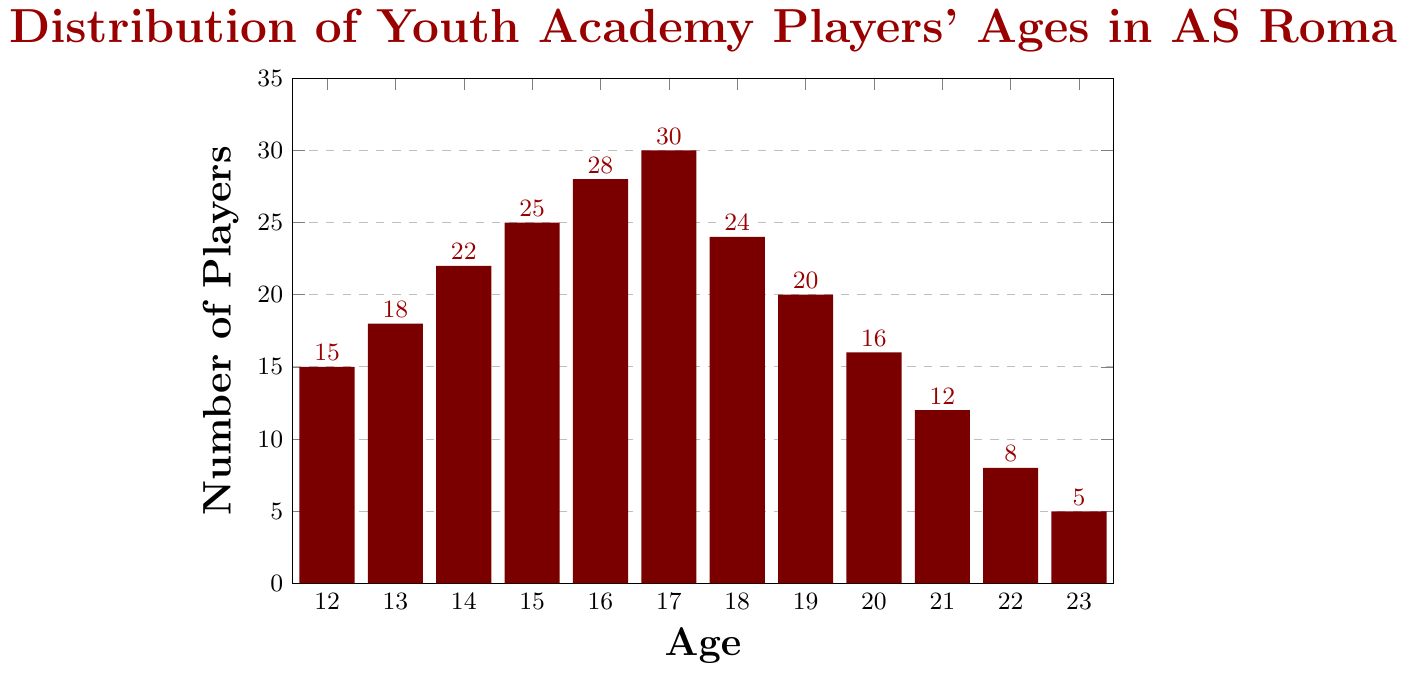What's the most common age of youth academy players in AS Roma's system? The bar representing age 17 is the tallest, indicating that this age group has the highest number of players.
Answer: 17 Which age group has the lowest number of players? The bar representing age 23 is the shortest, which means that this age group has the lowest number of players.
Answer: 23 What is the total number of players aged between 15 and 17? Add the number of players for ages 15, 16, and 17: 25 (age 15) + 28 (age 16) + 30 (age 17) = 83.
Answer: 83 How many more players are there at age 16 than at age 21? Subtract the number of players at age 21 from age 16: 28 (age 16) - 12 (age 21) = 16.
Answer: 16 Which age group has more players, age 14 or age 18? The bar for age 14 is slightly shorter than the bar for age 18. So, age 18 has more players.
Answer: Age 18 How does the number of players change as they age from 12 to 17? The number of players increases from 12 to 17, reaching a peak at age 17 with 30 players.
Answer: Increases What's the average number of players aged 19 to 22? Add the number of players for ages 19, 20, 21, and 22, then divide by 4: (20 + 16 + 12 + 8) / 4 = 56 / 4 = 14.
Answer: 14 Are there more players aged 12-14 or aged 21-23? Sum the number of players for ages 12, 13, and 14: 15 (age 12) + 18 (age 13) + 22 (age 14) = 55. Sum the number of players for ages 21, 22, and 23: 12 (age 21) + 8 (age 22) + 5 (age 23) = 25. So, there are more players aged 12-14.
Answer: Aged 12-14 Which age range shows a continuous decrease in the number of players? Observing the bars, the age range from 17 to 23 shows a consistent decrease in the number of players each year.
Answer: 17-23 